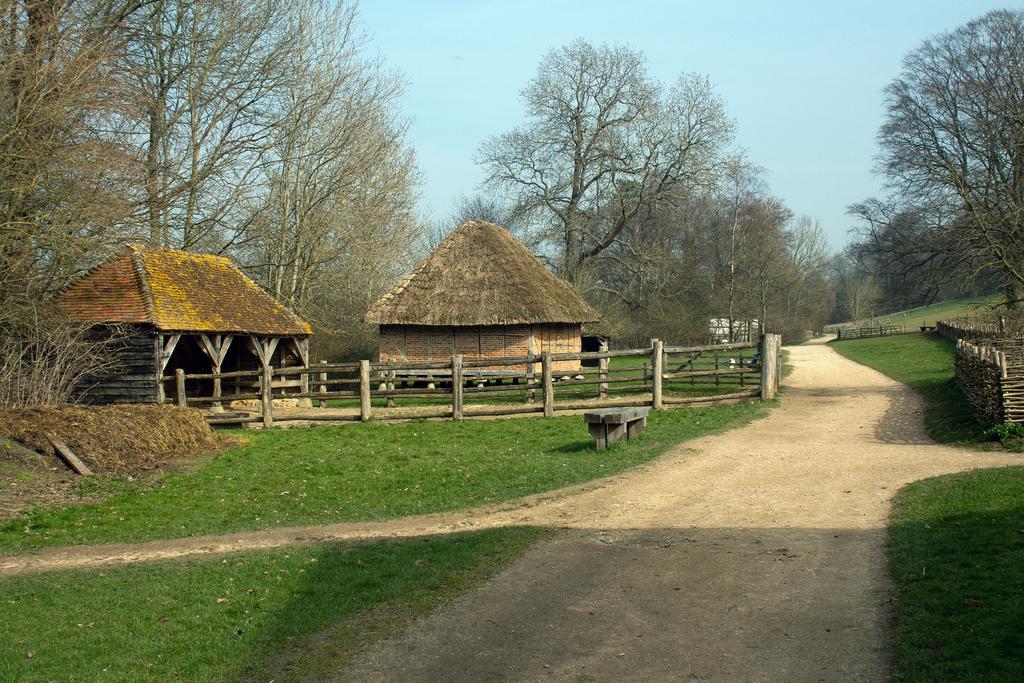Please provide a concise description of this image. In this picture I can observe two huts. There is a wooden railing. I can observe some grass on the ground. There is a path on the right side. In the background there are trees and a sky. 